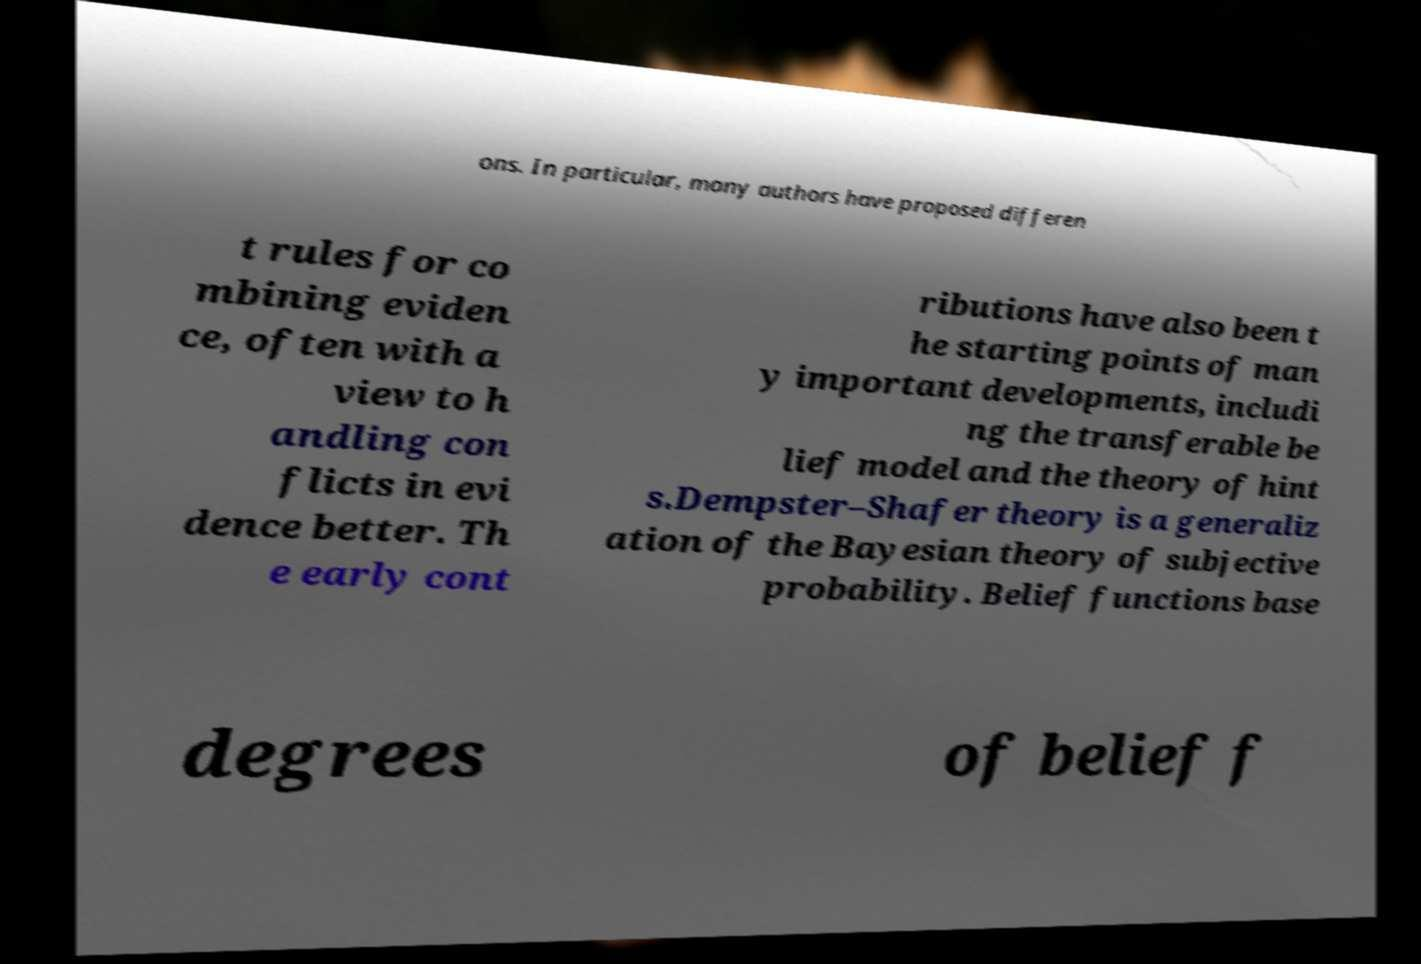What messages or text are displayed in this image? I need them in a readable, typed format. ons. In particular, many authors have proposed differen t rules for co mbining eviden ce, often with a view to h andling con flicts in evi dence better. Th e early cont ributions have also been t he starting points of man y important developments, includi ng the transferable be lief model and the theory of hint s.Dempster–Shafer theory is a generaliz ation of the Bayesian theory of subjective probability. Belief functions base degrees of belief f 